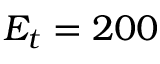<formula> <loc_0><loc_0><loc_500><loc_500>E _ { t } = 2 0 0</formula> 